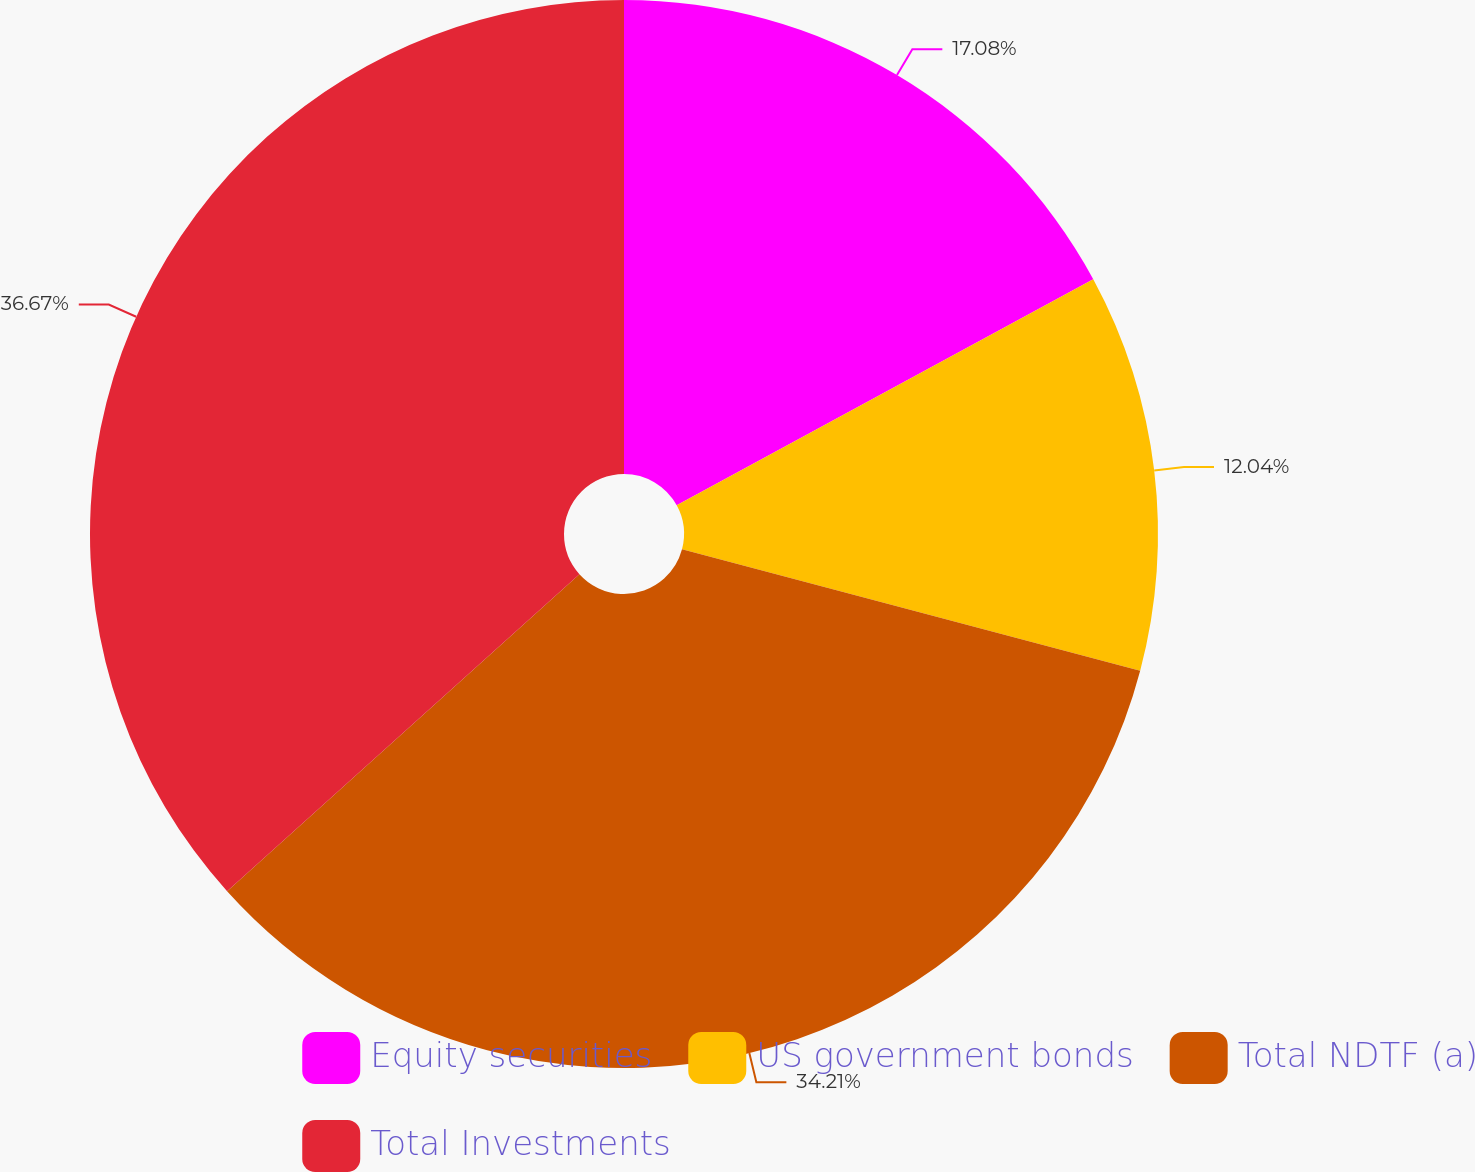Convert chart. <chart><loc_0><loc_0><loc_500><loc_500><pie_chart><fcel>Equity securities<fcel>US government bonds<fcel>Total NDTF (a)<fcel>Total Investments<nl><fcel>17.08%<fcel>12.04%<fcel>34.21%<fcel>36.66%<nl></chart> 